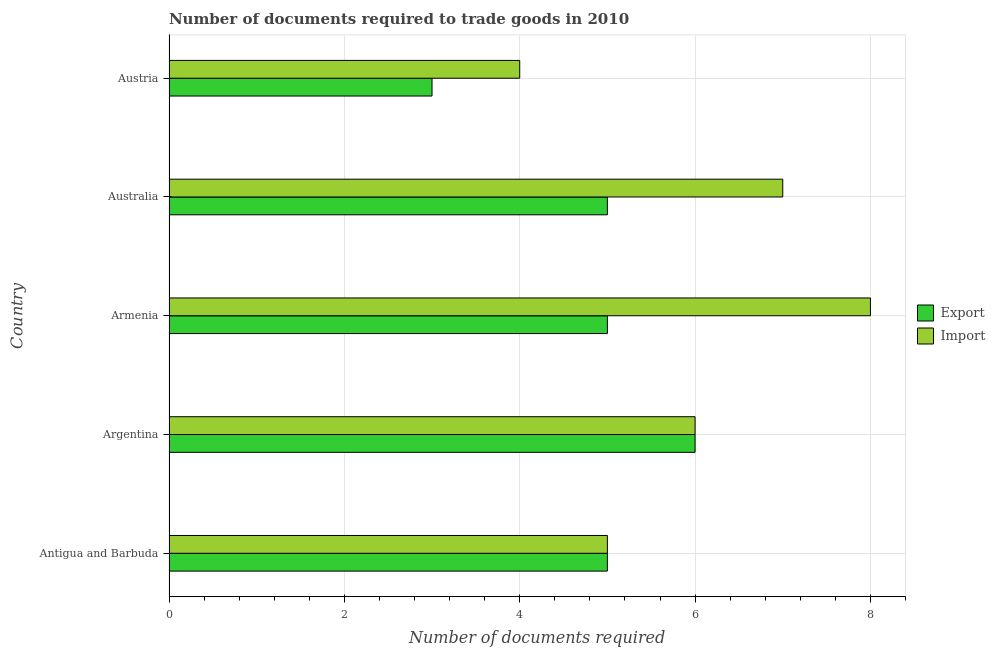How many different coloured bars are there?
Keep it short and to the point. 2. Are the number of bars on each tick of the Y-axis equal?
Make the answer very short. Yes. What is the label of the 2nd group of bars from the top?
Your response must be concise. Australia. What is the number of documents required to import goods in Armenia?
Provide a succinct answer. 8. In which country was the number of documents required to export goods maximum?
Offer a terse response. Argentina. What is the difference between the number of documents required to import goods in Argentina and the number of documents required to export goods in Australia?
Your response must be concise. 1. What is the average number of documents required to import goods per country?
Your answer should be very brief. 6. What is the difference between the number of documents required to export goods and number of documents required to import goods in Australia?
Your response must be concise. -2. What is the ratio of the number of documents required to export goods in Antigua and Barbuda to that in Austria?
Give a very brief answer. 1.67. Is the difference between the number of documents required to export goods in Antigua and Barbuda and Australia greater than the difference between the number of documents required to import goods in Antigua and Barbuda and Australia?
Offer a terse response. Yes. What is the difference between the highest and the lowest number of documents required to export goods?
Ensure brevity in your answer.  3. In how many countries, is the number of documents required to import goods greater than the average number of documents required to import goods taken over all countries?
Make the answer very short. 2. Is the sum of the number of documents required to import goods in Argentina and Armenia greater than the maximum number of documents required to export goods across all countries?
Ensure brevity in your answer.  Yes. What does the 2nd bar from the top in Armenia represents?
Offer a very short reply. Export. What does the 1st bar from the bottom in Armenia represents?
Make the answer very short. Export. How many bars are there?
Provide a succinct answer. 10. How many countries are there in the graph?
Provide a succinct answer. 5. Does the graph contain any zero values?
Give a very brief answer. No. Does the graph contain grids?
Your answer should be compact. Yes. Where does the legend appear in the graph?
Make the answer very short. Center right. How many legend labels are there?
Your response must be concise. 2. What is the title of the graph?
Keep it short and to the point. Number of documents required to trade goods in 2010. What is the label or title of the X-axis?
Offer a very short reply. Number of documents required. What is the Number of documents required in Export in Antigua and Barbuda?
Your response must be concise. 5. What is the Number of documents required in Import in Antigua and Barbuda?
Make the answer very short. 5. What is the Number of documents required of Import in Argentina?
Your answer should be very brief. 6. What is the Number of documents required of Export in Armenia?
Give a very brief answer. 5. What is the Number of documents required of Import in Armenia?
Keep it short and to the point. 8. What is the Number of documents required of Export in Australia?
Ensure brevity in your answer.  5. Across all countries, what is the maximum Number of documents required of Export?
Your answer should be compact. 6. Across all countries, what is the minimum Number of documents required in Export?
Offer a terse response. 3. What is the total Number of documents required of Import in the graph?
Give a very brief answer. 30. What is the difference between the Number of documents required in Import in Antigua and Barbuda and that in Argentina?
Ensure brevity in your answer.  -1. What is the difference between the Number of documents required of Export in Antigua and Barbuda and that in Armenia?
Make the answer very short. 0. What is the difference between the Number of documents required in Import in Antigua and Barbuda and that in Armenia?
Give a very brief answer. -3. What is the difference between the Number of documents required of Export in Argentina and that in Armenia?
Offer a terse response. 1. What is the difference between the Number of documents required of Export in Argentina and that in Australia?
Provide a short and direct response. 1. What is the difference between the Number of documents required of Import in Argentina and that in Australia?
Keep it short and to the point. -1. What is the difference between the Number of documents required of Export in Australia and that in Austria?
Make the answer very short. 2. What is the difference between the Number of documents required of Import in Australia and that in Austria?
Ensure brevity in your answer.  3. What is the difference between the Number of documents required of Export in Antigua and Barbuda and the Number of documents required of Import in Argentina?
Make the answer very short. -1. What is the difference between the Number of documents required in Export in Armenia and the Number of documents required in Import in Australia?
Keep it short and to the point. -2. What is the difference between the Number of documents required in Export and Number of documents required in Import in Antigua and Barbuda?
Offer a very short reply. 0. What is the difference between the Number of documents required in Export and Number of documents required in Import in Argentina?
Provide a short and direct response. 0. What is the ratio of the Number of documents required in Export in Antigua and Barbuda to that in Argentina?
Offer a terse response. 0.83. What is the ratio of the Number of documents required in Import in Antigua and Barbuda to that in Argentina?
Offer a very short reply. 0.83. What is the ratio of the Number of documents required in Import in Antigua and Barbuda to that in Australia?
Provide a succinct answer. 0.71. What is the ratio of the Number of documents required of Export in Antigua and Barbuda to that in Austria?
Provide a short and direct response. 1.67. What is the ratio of the Number of documents required of Export in Argentina to that in Armenia?
Your answer should be compact. 1.2. What is the ratio of the Number of documents required in Import in Argentina to that in Armenia?
Keep it short and to the point. 0.75. What is the ratio of the Number of documents required in Export in Argentina to that in Australia?
Your answer should be compact. 1.2. What is the ratio of the Number of documents required of Import in Argentina to that in Australia?
Provide a short and direct response. 0.86. What is the ratio of the Number of documents required in Import in Argentina to that in Austria?
Ensure brevity in your answer.  1.5. What is the ratio of the Number of documents required of Export in Armenia to that in Australia?
Make the answer very short. 1. What is the ratio of the Number of documents required of Export in Armenia to that in Austria?
Make the answer very short. 1.67. What is the ratio of the Number of documents required in Export in Australia to that in Austria?
Offer a very short reply. 1.67. What is the difference between the highest and the second highest Number of documents required in Import?
Offer a very short reply. 1. What is the difference between the highest and the lowest Number of documents required of Export?
Ensure brevity in your answer.  3. 